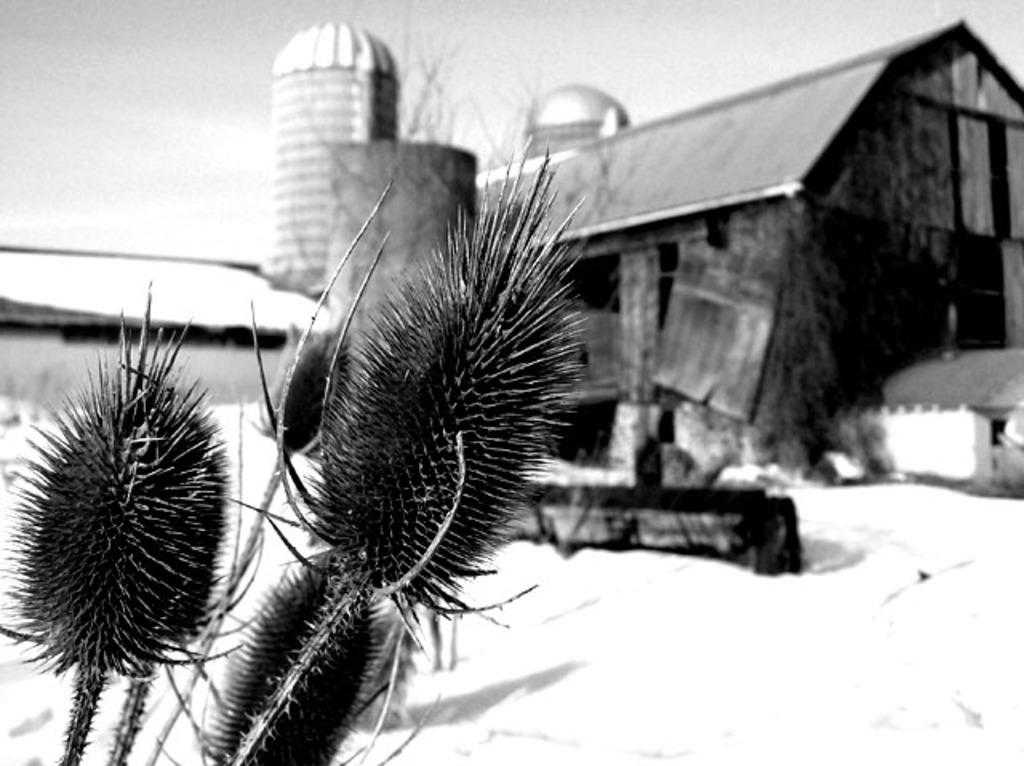What is the color scheme of the image? The image is black and white. What type of vegetation can be seen in the image? There are plants in the image. What is the weather condition in the image? There is snow in the image. What type of structure is present in the image? There is a house in the image. What other natural element is visible in the image? There is a tree in the image. What is visible in the background of the image? The sky is visible in the image. What type of stitch is used to sew the coast in the image? There is no coast or stitching present in the image; it features a black and white scene with plants, snow, a house, a tree, and a visible sky. 